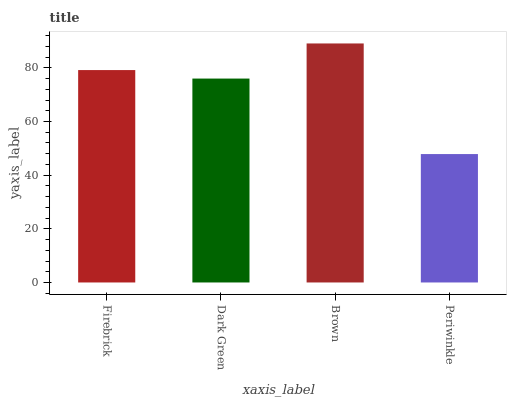Is Periwinkle the minimum?
Answer yes or no. Yes. Is Brown the maximum?
Answer yes or no. Yes. Is Dark Green the minimum?
Answer yes or no. No. Is Dark Green the maximum?
Answer yes or no. No. Is Firebrick greater than Dark Green?
Answer yes or no. Yes. Is Dark Green less than Firebrick?
Answer yes or no. Yes. Is Dark Green greater than Firebrick?
Answer yes or no. No. Is Firebrick less than Dark Green?
Answer yes or no. No. Is Firebrick the high median?
Answer yes or no. Yes. Is Dark Green the low median?
Answer yes or no. Yes. Is Brown the high median?
Answer yes or no. No. Is Firebrick the low median?
Answer yes or no. No. 